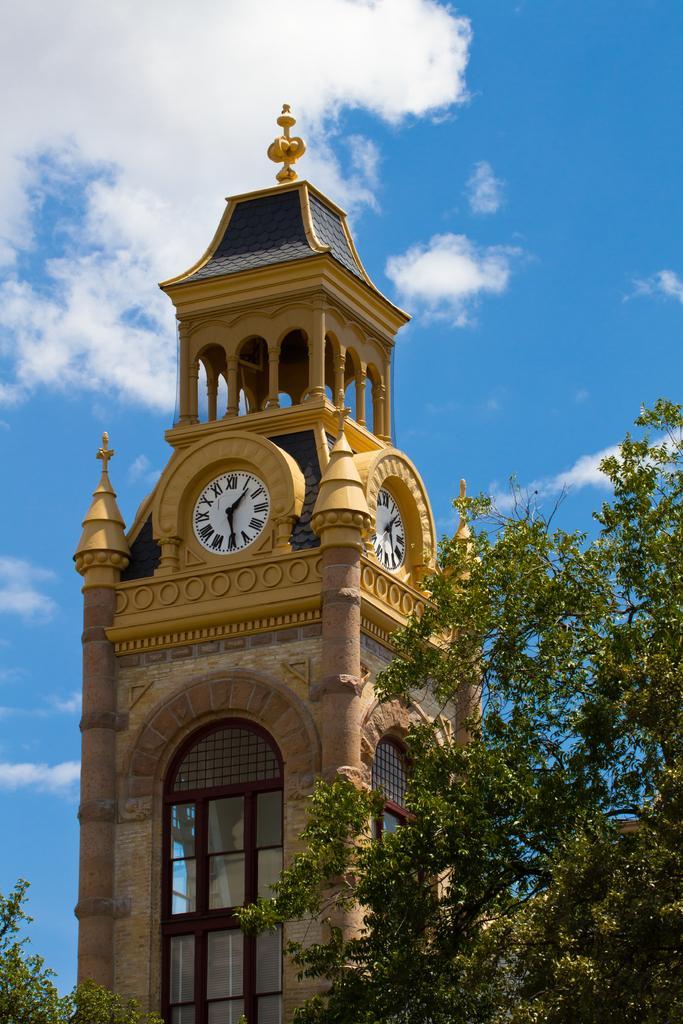Describe this image in one or two sentences. In this image we can see a clock tower, trees and sky with clouds in the background. 